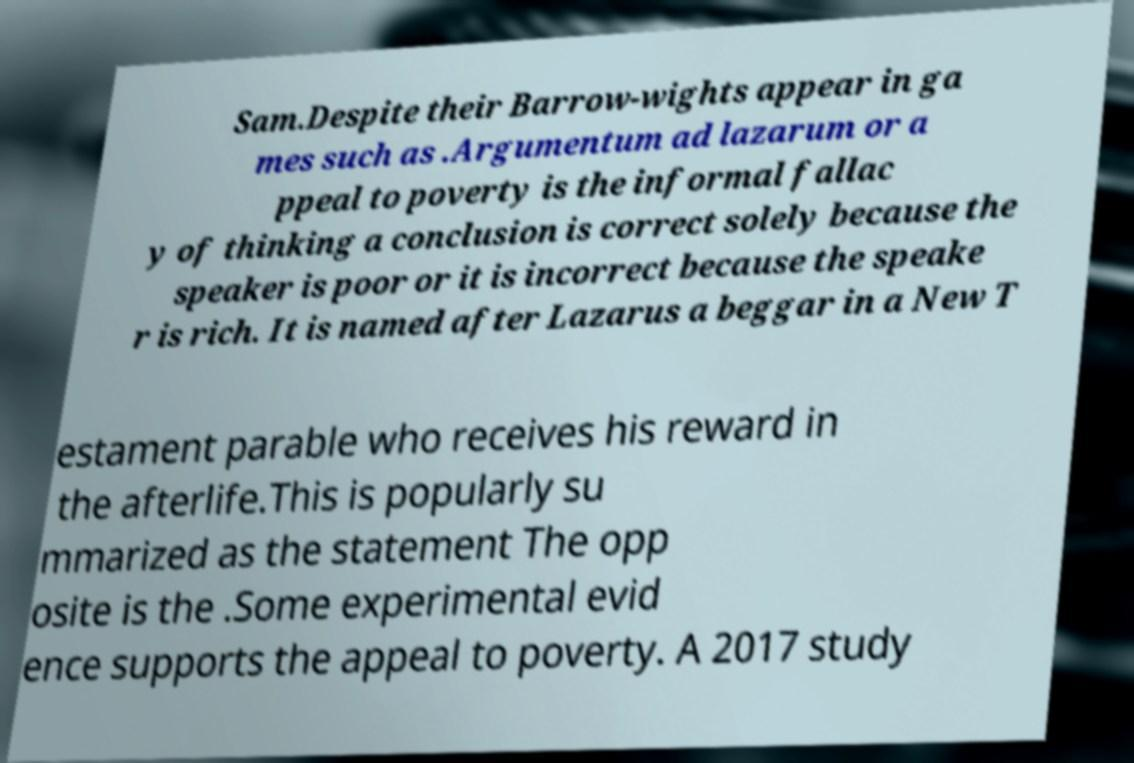What messages or text are displayed in this image? I need them in a readable, typed format. Sam.Despite their Barrow-wights appear in ga mes such as .Argumentum ad lazarum or a ppeal to poverty is the informal fallac y of thinking a conclusion is correct solely because the speaker is poor or it is incorrect because the speake r is rich. It is named after Lazarus a beggar in a New T estament parable who receives his reward in the afterlife.This is popularly su mmarized as the statement The opp osite is the .Some experimental evid ence supports the appeal to poverty. A 2017 study 